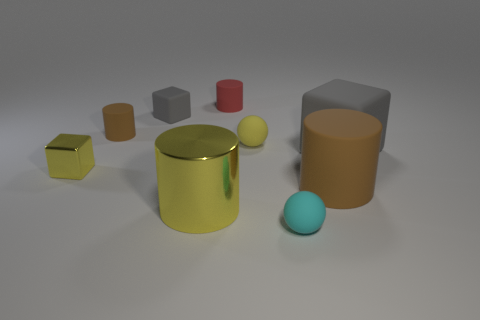Add 1 small red things. How many objects exist? 10 Subtract all cylinders. How many objects are left? 5 Subtract all tiny green matte things. Subtract all spheres. How many objects are left? 7 Add 8 big yellow cylinders. How many big yellow cylinders are left? 9 Add 5 red rubber balls. How many red rubber balls exist? 5 Subtract 1 yellow spheres. How many objects are left? 8 